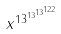Convert formula to latex. <formula><loc_0><loc_0><loc_500><loc_500>x ^ { 1 3 ^ { 1 3 ^ { 1 3 ^ { 1 2 2 } } } }</formula> 